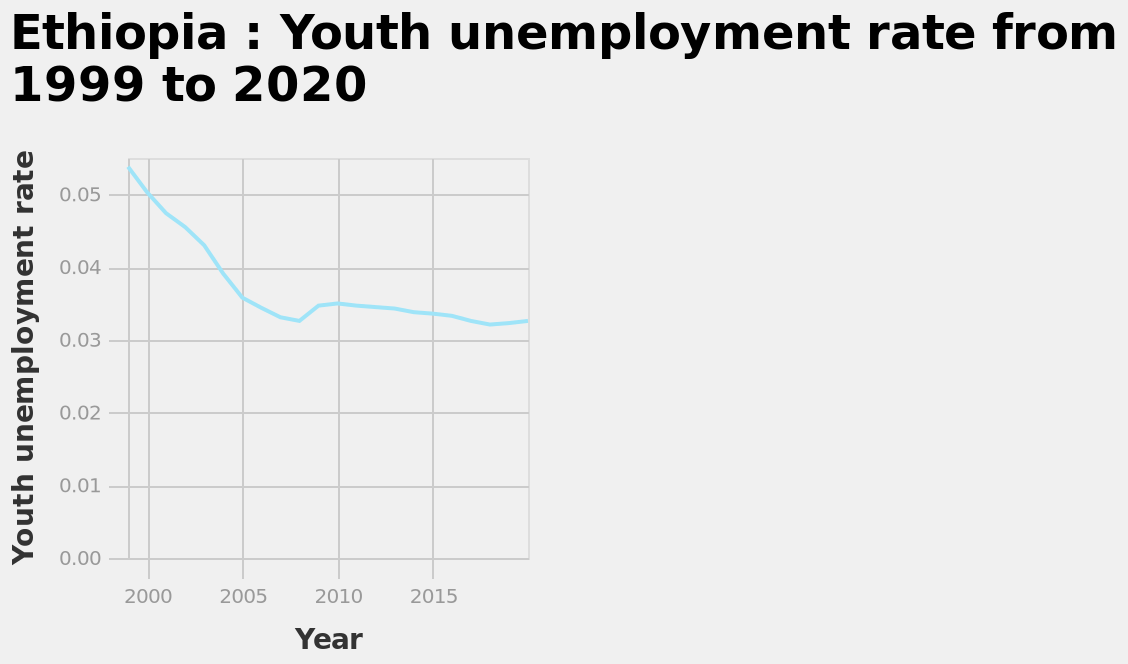<image>
please enumerates aspects of the construction of the chart This is a line chart titled Ethiopia : Youth unemployment rate from 1999 to 2020. There is a linear scale of range 2000 to 2015 along the x-axis, labeled Year. The y-axis shows Youth unemployment rate. Did youth unemployment continue to decrease after 2005?  After 2005, the rate at which youth unemployment fell began to slow. Did youth unemployment in Ethiopia reach the same levels as in 1999?  No, youth unemployment in Ethiopia did not reach the same levels as in 1999. What is the range of values on the x-axis?  The x-axis has a linear scale ranging from 2000 to 2015, representing the years. What is the title of the line chart?  The title of the line chart is "Ethiopia: Youth unemployment rate from 1999 to 2020." 